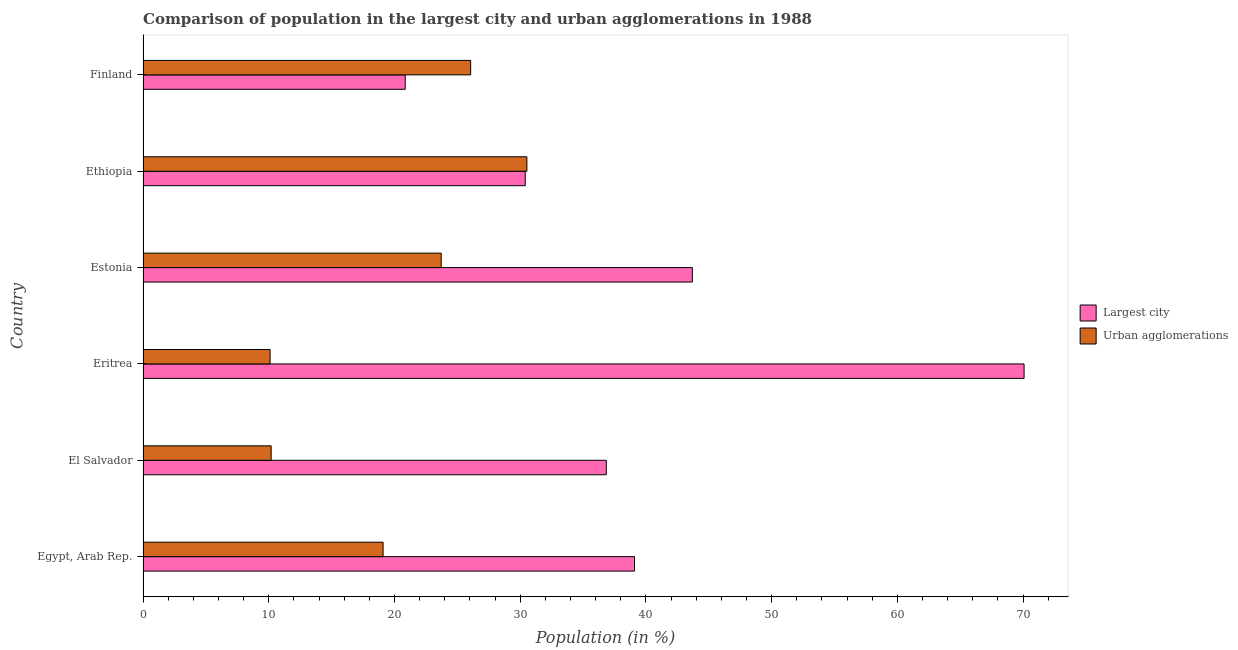How many different coloured bars are there?
Provide a succinct answer. 2. Are the number of bars on each tick of the Y-axis equal?
Ensure brevity in your answer.  Yes. How many bars are there on the 3rd tick from the bottom?
Give a very brief answer. 2. What is the label of the 5th group of bars from the top?
Ensure brevity in your answer.  El Salvador. What is the population in the largest city in Ethiopia?
Your answer should be very brief. 30.4. Across all countries, what is the maximum population in the largest city?
Keep it short and to the point. 70.08. Across all countries, what is the minimum population in the largest city?
Give a very brief answer. 20.85. In which country was the population in urban agglomerations maximum?
Provide a short and direct response. Ethiopia. What is the total population in urban agglomerations in the graph?
Provide a short and direct response. 119.69. What is the difference between the population in urban agglomerations in Eritrea and that in Finland?
Give a very brief answer. -15.96. What is the difference between the population in the largest city in Eritrea and the population in urban agglomerations in El Salvador?
Your response must be concise. 59.89. What is the average population in urban agglomerations per country?
Give a very brief answer. 19.95. What is the difference between the population in urban agglomerations and population in the largest city in Egypt, Arab Rep.?
Your answer should be compact. -20. In how many countries, is the population in the largest city greater than 66 %?
Provide a succinct answer. 1. What is the ratio of the population in urban agglomerations in Egypt, Arab Rep. to that in Eritrea?
Provide a short and direct response. 1.89. Is the population in the largest city in Eritrea less than that in Finland?
Provide a succinct answer. No. Is the difference between the population in urban agglomerations in El Salvador and Ethiopia greater than the difference between the population in the largest city in El Salvador and Ethiopia?
Your answer should be compact. No. What is the difference between the highest and the second highest population in the largest city?
Provide a succinct answer. 26.39. What is the difference between the highest and the lowest population in the largest city?
Your answer should be very brief. 49.23. In how many countries, is the population in the largest city greater than the average population in the largest city taken over all countries?
Give a very brief answer. 2. What does the 1st bar from the top in El Salvador represents?
Offer a terse response. Urban agglomerations. What does the 1st bar from the bottom in Finland represents?
Offer a very short reply. Largest city. Does the graph contain any zero values?
Keep it short and to the point. No. Where does the legend appear in the graph?
Give a very brief answer. Center right. How many legend labels are there?
Offer a very short reply. 2. What is the title of the graph?
Provide a succinct answer. Comparison of population in the largest city and urban agglomerations in 1988. What is the label or title of the Y-axis?
Your answer should be compact. Country. What is the Population (in %) of Largest city in Egypt, Arab Rep.?
Provide a succinct answer. 39.09. What is the Population (in %) of Urban agglomerations in Egypt, Arab Rep.?
Your answer should be very brief. 19.09. What is the Population (in %) in Largest city in El Salvador?
Ensure brevity in your answer.  36.85. What is the Population (in %) in Urban agglomerations in El Salvador?
Your answer should be very brief. 10.19. What is the Population (in %) in Largest city in Eritrea?
Give a very brief answer. 70.08. What is the Population (in %) of Urban agglomerations in Eritrea?
Your response must be concise. 10.1. What is the Population (in %) of Largest city in Estonia?
Keep it short and to the point. 43.69. What is the Population (in %) of Urban agglomerations in Estonia?
Your answer should be compact. 23.71. What is the Population (in %) of Largest city in Ethiopia?
Provide a short and direct response. 30.4. What is the Population (in %) in Urban agglomerations in Ethiopia?
Keep it short and to the point. 30.53. What is the Population (in %) of Largest city in Finland?
Ensure brevity in your answer.  20.85. What is the Population (in %) in Urban agglomerations in Finland?
Keep it short and to the point. 26.06. Across all countries, what is the maximum Population (in %) in Largest city?
Your answer should be very brief. 70.08. Across all countries, what is the maximum Population (in %) of Urban agglomerations?
Give a very brief answer. 30.53. Across all countries, what is the minimum Population (in %) in Largest city?
Keep it short and to the point. 20.85. Across all countries, what is the minimum Population (in %) of Urban agglomerations?
Provide a succinct answer. 10.1. What is the total Population (in %) in Largest city in the graph?
Give a very brief answer. 240.96. What is the total Population (in %) of Urban agglomerations in the graph?
Your answer should be compact. 119.69. What is the difference between the Population (in %) of Largest city in Egypt, Arab Rep. and that in El Salvador?
Your response must be concise. 2.24. What is the difference between the Population (in %) in Urban agglomerations in Egypt, Arab Rep. and that in El Salvador?
Ensure brevity in your answer.  8.9. What is the difference between the Population (in %) of Largest city in Egypt, Arab Rep. and that in Eritrea?
Provide a short and direct response. -30.99. What is the difference between the Population (in %) in Urban agglomerations in Egypt, Arab Rep. and that in Eritrea?
Provide a short and direct response. 8.99. What is the difference between the Population (in %) in Largest city in Egypt, Arab Rep. and that in Estonia?
Offer a very short reply. -4.6. What is the difference between the Population (in %) of Urban agglomerations in Egypt, Arab Rep. and that in Estonia?
Your answer should be compact. -4.62. What is the difference between the Population (in %) in Largest city in Egypt, Arab Rep. and that in Ethiopia?
Offer a very short reply. 8.69. What is the difference between the Population (in %) in Urban agglomerations in Egypt, Arab Rep. and that in Ethiopia?
Provide a succinct answer. -11.44. What is the difference between the Population (in %) in Largest city in Egypt, Arab Rep. and that in Finland?
Offer a terse response. 18.24. What is the difference between the Population (in %) of Urban agglomerations in Egypt, Arab Rep. and that in Finland?
Offer a very short reply. -6.97. What is the difference between the Population (in %) of Largest city in El Salvador and that in Eritrea?
Your answer should be compact. -33.23. What is the difference between the Population (in %) of Urban agglomerations in El Salvador and that in Eritrea?
Provide a succinct answer. 0.08. What is the difference between the Population (in %) in Largest city in El Salvador and that in Estonia?
Your response must be concise. -6.85. What is the difference between the Population (in %) in Urban agglomerations in El Salvador and that in Estonia?
Provide a short and direct response. -13.53. What is the difference between the Population (in %) of Largest city in El Salvador and that in Ethiopia?
Ensure brevity in your answer.  6.45. What is the difference between the Population (in %) in Urban agglomerations in El Salvador and that in Ethiopia?
Make the answer very short. -20.34. What is the difference between the Population (in %) in Largest city in El Salvador and that in Finland?
Keep it short and to the point. 16. What is the difference between the Population (in %) in Urban agglomerations in El Salvador and that in Finland?
Make the answer very short. -15.87. What is the difference between the Population (in %) in Largest city in Eritrea and that in Estonia?
Your answer should be compact. 26.39. What is the difference between the Population (in %) in Urban agglomerations in Eritrea and that in Estonia?
Provide a succinct answer. -13.61. What is the difference between the Population (in %) of Largest city in Eritrea and that in Ethiopia?
Keep it short and to the point. 39.68. What is the difference between the Population (in %) of Urban agglomerations in Eritrea and that in Ethiopia?
Keep it short and to the point. -20.43. What is the difference between the Population (in %) in Largest city in Eritrea and that in Finland?
Keep it short and to the point. 49.23. What is the difference between the Population (in %) in Urban agglomerations in Eritrea and that in Finland?
Keep it short and to the point. -15.95. What is the difference between the Population (in %) in Largest city in Estonia and that in Ethiopia?
Make the answer very short. 13.29. What is the difference between the Population (in %) in Urban agglomerations in Estonia and that in Ethiopia?
Give a very brief answer. -6.82. What is the difference between the Population (in %) of Largest city in Estonia and that in Finland?
Offer a terse response. 22.84. What is the difference between the Population (in %) in Urban agglomerations in Estonia and that in Finland?
Your response must be concise. -2.34. What is the difference between the Population (in %) of Largest city in Ethiopia and that in Finland?
Your answer should be very brief. 9.55. What is the difference between the Population (in %) in Urban agglomerations in Ethiopia and that in Finland?
Provide a succinct answer. 4.47. What is the difference between the Population (in %) of Largest city in Egypt, Arab Rep. and the Population (in %) of Urban agglomerations in El Salvador?
Ensure brevity in your answer.  28.9. What is the difference between the Population (in %) in Largest city in Egypt, Arab Rep. and the Population (in %) in Urban agglomerations in Eritrea?
Make the answer very short. 28.99. What is the difference between the Population (in %) in Largest city in Egypt, Arab Rep. and the Population (in %) in Urban agglomerations in Estonia?
Ensure brevity in your answer.  15.38. What is the difference between the Population (in %) of Largest city in Egypt, Arab Rep. and the Population (in %) of Urban agglomerations in Ethiopia?
Keep it short and to the point. 8.56. What is the difference between the Population (in %) in Largest city in Egypt, Arab Rep. and the Population (in %) in Urban agglomerations in Finland?
Make the answer very short. 13.03. What is the difference between the Population (in %) of Largest city in El Salvador and the Population (in %) of Urban agglomerations in Eritrea?
Your response must be concise. 26.74. What is the difference between the Population (in %) of Largest city in El Salvador and the Population (in %) of Urban agglomerations in Estonia?
Provide a short and direct response. 13.13. What is the difference between the Population (in %) of Largest city in El Salvador and the Population (in %) of Urban agglomerations in Ethiopia?
Ensure brevity in your answer.  6.32. What is the difference between the Population (in %) in Largest city in El Salvador and the Population (in %) in Urban agglomerations in Finland?
Provide a short and direct response. 10.79. What is the difference between the Population (in %) in Largest city in Eritrea and the Population (in %) in Urban agglomerations in Estonia?
Offer a terse response. 46.37. What is the difference between the Population (in %) of Largest city in Eritrea and the Population (in %) of Urban agglomerations in Ethiopia?
Ensure brevity in your answer.  39.55. What is the difference between the Population (in %) in Largest city in Eritrea and the Population (in %) in Urban agglomerations in Finland?
Offer a terse response. 44.02. What is the difference between the Population (in %) of Largest city in Estonia and the Population (in %) of Urban agglomerations in Ethiopia?
Your answer should be compact. 13.16. What is the difference between the Population (in %) of Largest city in Estonia and the Population (in %) of Urban agglomerations in Finland?
Your response must be concise. 17.63. What is the difference between the Population (in %) of Largest city in Ethiopia and the Population (in %) of Urban agglomerations in Finland?
Give a very brief answer. 4.34. What is the average Population (in %) in Largest city per country?
Make the answer very short. 40.16. What is the average Population (in %) of Urban agglomerations per country?
Offer a terse response. 19.95. What is the difference between the Population (in %) of Largest city and Population (in %) of Urban agglomerations in Egypt, Arab Rep.?
Your answer should be compact. 20. What is the difference between the Population (in %) in Largest city and Population (in %) in Urban agglomerations in El Salvador?
Offer a terse response. 26.66. What is the difference between the Population (in %) in Largest city and Population (in %) in Urban agglomerations in Eritrea?
Provide a succinct answer. 59.98. What is the difference between the Population (in %) of Largest city and Population (in %) of Urban agglomerations in Estonia?
Give a very brief answer. 19.98. What is the difference between the Population (in %) of Largest city and Population (in %) of Urban agglomerations in Ethiopia?
Offer a terse response. -0.13. What is the difference between the Population (in %) of Largest city and Population (in %) of Urban agglomerations in Finland?
Your answer should be very brief. -5.21. What is the ratio of the Population (in %) in Largest city in Egypt, Arab Rep. to that in El Salvador?
Offer a very short reply. 1.06. What is the ratio of the Population (in %) of Urban agglomerations in Egypt, Arab Rep. to that in El Salvador?
Ensure brevity in your answer.  1.87. What is the ratio of the Population (in %) in Largest city in Egypt, Arab Rep. to that in Eritrea?
Give a very brief answer. 0.56. What is the ratio of the Population (in %) in Urban agglomerations in Egypt, Arab Rep. to that in Eritrea?
Your answer should be very brief. 1.89. What is the ratio of the Population (in %) in Largest city in Egypt, Arab Rep. to that in Estonia?
Your response must be concise. 0.89. What is the ratio of the Population (in %) in Urban agglomerations in Egypt, Arab Rep. to that in Estonia?
Give a very brief answer. 0.81. What is the ratio of the Population (in %) in Largest city in Egypt, Arab Rep. to that in Ethiopia?
Provide a short and direct response. 1.29. What is the ratio of the Population (in %) of Urban agglomerations in Egypt, Arab Rep. to that in Ethiopia?
Provide a succinct answer. 0.63. What is the ratio of the Population (in %) in Largest city in Egypt, Arab Rep. to that in Finland?
Offer a terse response. 1.87. What is the ratio of the Population (in %) of Urban agglomerations in Egypt, Arab Rep. to that in Finland?
Keep it short and to the point. 0.73. What is the ratio of the Population (in %) in Largest city in El Salvador to that in Eritrea?
Make the answer very short. 0.53. What is the ratio of the Population (in %) of Urban agglomerations in El Salvador to that in Eritrea?
Give a very brief answer. 1.01. What is the ratio of the Population (in %) of Largest city in El Salvador to that in Estonia?
Make the answer very short. 0.84. What is the ratio of the Population (in %) in Urban agglomerations in El Salvador to that in Estonia?
Offer a very short reply. 0.43. What is the ratio of the Population (in %) of Largest city in El Salvador to that in Ethiopia?
Provide a short and direct response. 1.21. What is the ratio of the Population (in %) of Urban agglomerations in El Salvador to that in Ethiopia?
Give a very brief answer. 0.33. What is the ratio of the Population (in %) of Largest city in El Salvador to that in Finland?
Give a very brief answer. 1.77. What is the ratio of the Population (in %) in Urban agglomerations in El Salvador to that in Finland?
Your answer should be very brief. 0.39. What is the ratio of the Population (in %) in Largest city in Eritrea to that in Estonia?
Ensure brevity in your answer.  1.6. What is the ratio of the Population (in %) in Urban agglomerations in Eritrea to that in Estonia?
Provide a short and direct response. 0.43. What is the ratio of the Population (in %) in Largest city in Eritrea to that in Ethiopia?
Make the answer very short. 2.31. What is the ratio of the Population (in %) of Urban agglomerations in Eritrea to that in Ethiopia?
Your answer should be very brief. 0.33. What is the ratio of the Population (in %) in Largest city in Eritrea to that in Finland?
Your answer should be compact. 3.36. What is the ratio of the Population (in %) of Urban agglomerations in Eritrea to that in Finland?
Your answer should be compact. 0.39. What is the ratio of the Population (in %) of Largest city in Estonia to that in Ethiopia?
Keep it short and to the point. 1.44. What is the ratio of the Population (in %) in Urban agglomerations in Estonia to that in Ethiopia?
Offer a terse response. 0.78. What is the ratio of the Population (in %) in Largest city in Estonia to that in Finland?
Your answer should be compact. 2.1. What is the ratio of the Population (in %) of Urban agglomerations in Estonia to that in Finland?
Give a very brief answer. 0.91. What is the ratio of the Population (in %) of Largest city in Ethiopia to that in Finland?
Offer a terse response. 1.46. What is the ratio of the Population (in %) of Urban agglomerations in Ethiopia to that in Finland?
Offer a very short reply. 1.17. What is the difference between the highest and the second highest Population (in %) in Largest city?
Keep it short and to the point. 26.39. What is the difference between the highest and the second highest Population (in %) of Urban agglomerations?
Offer a very short reply. 4.47. What is the difference between the highest and the lowest Population (in %) of Largest city?
Provide a succinct answer. 49.23. What is the difference between the highest and the lowest Population (in %) of Urban agglomerations?
Make the answer very short. 20.43. 